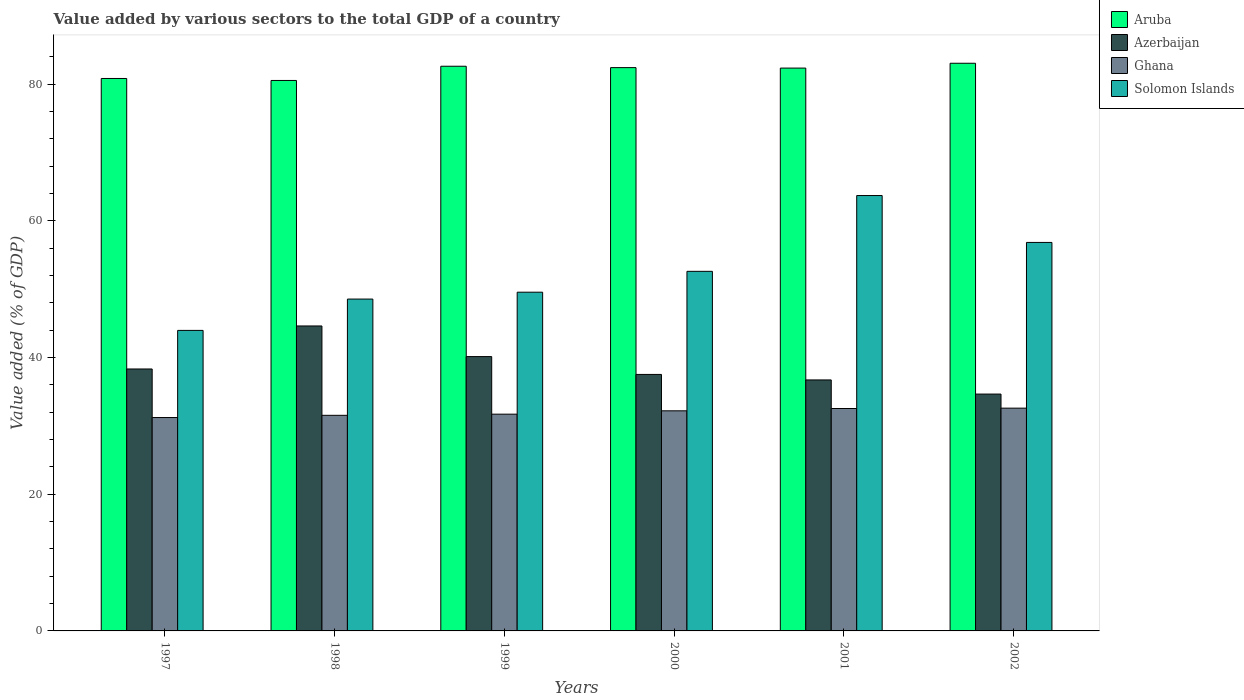How many different coloured bars are there?
Provide a short and direct response. 4. Are the number of bars per tick equal to the number of legend labels?
Offer a very short reply. Yes. How many bars are there on the 5th tick from the left?
Your answer should be compact. 4. How many bars are there on the 4th tick from the right?
Give a very brief answer. 4. In how many cases, is the number of bars for a given year not equal to the number of legend labels?
Your answer should be compact. 0. What is the value added by various sectors to the total GDP in Aruba in 1998?
Keep it short and to the point. 80.53. Across all years, what is the maximum value added by various sectors to the total GDP in Solomon Islands?
Make the answer very short. 63.69. Across all years, what is the minimum value added by various sectors to the total GDP in Azerbaijan?
Your response must be concise. 34.65. In which year was the value added by various sectors to the total GDP in Ghana maximum?
Give a very brief answer. 2002. What is the total value added by various sectors to the total GDP in Aruba in the graph?
Your response must be concise. 491.75. What is the difference between the value added by various sectors to the total GDP in Azerbaijan in 1998 and that in 2000?
Provide a short and direct response. 7.09. What is the difference between the value added by various sectors to the total GDP in Azerbaijan in 1997 and the value added by various sectors to the total GDP in Aruba in 1998?
Provide a short and direct response. -42.21. What is the average value added by various sectors to the total GDP in Aruba per year?
Provide a short and direct response. 81.96. In the year 2002, what is the difference between the value added by various sectors to the total GDP in Solomon Islands and value added by various sectors to the total GDP in Azerbaijan?
Your answer should be very brief. 22.18. In how many years, is the value added by various sectors to the total GDP in Azerbaijan greater than 76 %?
Provide a succinct answer. 0. What is the ratio of the value added by various sectors to the total GDP in Solomon Islands in 2001 to that in 2002?
Ensure brevity in your answer.  1.12. Is the value added by various sectors to the total GDP in Ghana in 2000 less than that in 2001?
Offer a terse response. Yes. Is the difference between the value added by various sectors to the total GDP in Solomon Islands in 1999 and 2002 greater than the difference between the value added by various sectors to the total GDP in Azerbaijan in 1999 and 2002?
Ensure brevity in your answer.  No. What is the difference between the highest and the second highest value added by various sectors to the total GDP in Solomon Islands?
Make the answer very short. 6.86. What is the difference between the highest and the lowest value added by various sectors to the total GDP in Solomon Islands?
Ensure brevity in your answer.  19.73. In how many years, is the value added by various sectors to the total GDP in Azerbaijan greater than the average value added by various sectors to the total GDP in Azerbaijan taken over all years?
Your answer should be compact. 2. Is the sum of the value added by various sectors to the total GDP in Aruba in 1998 and 2001 greater than the maximum value added by various sectors to the total GDP in Azerbaijan across all years?
Keep it short and to the point. Yes. What does the 4th bar from the left in 1998 represents?
Offer a terse response. Solomon Islands. What does the 1st bar from the right in 2002 represents?
Keep it short and to the point. Solomon Islands. Is it the case that in every year, the sum of the value added by various sectors to the total GDP in Ghana and value added by various sectors to the total GDP in Solomon Islands is greater than the value added by various sectors to the total GDP in Azerbaijan?
Give a very brief answer. Yes. Are all the bars in the graph horizontal?
Your response must be concise. No. How many years are there in the graph?
Offer a very short reply. 6. What is the difference between two consecutive major ticks on the Y-axis?
Provide a short and direct response. 20. Are the values on the major ticks of Y-axis written in scientific E-notation?
Offer a terse response. No. Where does the legend appear in the graph?
Your answer should be very brief. Top right. How are the legend labels stacked?
Ensure brevity in your answer.  Vertical. What is the title of the graph?
Offer a terse response. Value added by various sectors to the total GDP of a country. Does "Czech Republic" appear as one of the legend labels in the graph?
Ensure brevity in your answer.  No. What is the label or title of the Y-axis?
Your answer should be very brief. Value added (% of GDP). What is the Value added (% of GDP) in Aruba in 1997?
Keep it short and to the point. 80.82. What is the Value added (% of GDP) of Azerbaijan in 1997?
Offer a very short reply. 38.32. What is the Value added (% of GDP) of Ghana in 1997?
Provide a short and direct response. 31.22. What is the Value added (% of GDP) of Solomon Islands in 1997?
Offer a very short reply. 43.96. What is the Value added (% of GDP) in Aruba in 1998?
Your answer should be very brief. 80.53. What is the Value added (% of GDP) in Azerbaijan in 1998?
Your response must be concise. 44.61. What is the Value added (% of GDP) in Ghana in 1998?
Offer a terse response. 31.54. What is the Value added (% of GDP) in Solomon Islands in 1998?
Make the answer very short. 48.55. What is the Value added (% of GDP) of Aruba in 1999?
Your answer should be very brief. 82.61. What is the Value added (% of GDP) in Azerbaijan in 1999?
Your answer should be very brief. 40.13. What is the Value added (% of GDP) in Ghana in 1999?
Provide a short and direct response. 31.71. What is the Value added (% of GDP) of Solomon Islands in 1999?
Your answer should be compact. 49.55. What is the Value added (% of GDP) in Aruba in 2000?
Make the answer very short. 82.41. What is the Value added (% of GDP) in Azerbaijan in 2000?
Provide a short and direct response. 37.52. What is the Value added (% of GDP) in Ghana in 2000?
Give a very brief answer. 32.2. What is the Value added (% of GDP) of Solomon Islands in 2000?
Offer a terse response. 52.6. What is the Value added (% of GDP) in Aruba in 2001?
Provide a succinct answer. 82.34. What is the Value added (% of GDP) in Azerbaijan in 2001?
Give a very brief answer. 36.72. What is the Value added (% of GDP) of Ghana in 2001?
Offer a terse response. 32.54. What is the Value added (% of GDP) in Solomon Islands in 2001?
Provide a short and direct response. 63.69. What is the Value added (% of GDP) in Aruba in 2002?
Offer a terse response. 83.04. What is the Value added (% of GDP) of Azerbaijan in 2002?
Keep it short and to the point. 34.65. What is the Value added (% of GDP) in Ghana in 2002?
Offer a very short reply. 32.59. What is the Value added (% of GDP) of Solomon Islands in 2002?
Make the answer very short. 56.83. Across all years, what is the maximum Value added (% of GDP) in Aruba?
Your response must be concise. 83.04. Across all years, what is the maximum Value added (% of GDP) in Azerbaijan?
Offer a terse response. 44.61. Across all years, what is the maximum Value added (% of GDP) in Ghana?
Offer a very short reply. 32.59. Across all years, what is the maximum Value added (% of GDP) of Solomon Islands?
Ensure brevity in your answer.  63.69. Across all years, what is the minimum Value added (% of GDP) of Aruba?
Ensure brevity in your answer.  80.53. Across all years, what is the minimum Value added (% of GDP) in Azerbaijan?
Offer a very short reply. 34.65. Across all years, what is the minimum Value added (% of GDP) of Ghana?
Offer a terse response. 31.22. Across all years, what is the minimum Value added (% of GDP) of Solomon Islands?
Your response must be concise. 43.96. What is the total Value added (% of GDP) in Aruba in the graph?
Provide a short and direct response. 491.75. What is the total Value added (% of GDP) in Azerbaijan in the graph?
Provide a short and direct response. 231.96. What is the total Value added (% of GDP) of Ghana in the graph?
Your response must be concise. 191.79. What is the total Value added (% of GDP) of Solomon Islands in the graph?
Provide a short and direct response. 315.2. What is the difference between the Value added (% of GDP) in Aruba in 1997 and that in 1998?
Provide a succinct answer. 0.29. What is the difference between the Value added (% of GDP) of Azerbaijan in 1997 and that in 1998?
Your response must be concise. -6.29. What is the difference between the Value added (% of GDP) of Ghana in 1997 and that in 1998?
Provide a short and direct response. -0.32. What is the difference between the Value added (% of GDP) in Solomon Islands in 1997 and that in 1998?
Offer a terse response. -4.59. What is the difference between the Value added (% of GDP) in Aruba in 1997 and that in 1999?
Make the answer very short. -1.79. What is the difference between the Value added (% of GDP) of Azerbaijan in 1997 and that in 1999?
Your answer should be compact. -1.81. What is the difference between the Value added (% of GDP) in Ghana in 1997 and that in 1999?
Make the answer very short. -0.49. What is the difference between the Value added (% of GDP) of Solomon Islands in 1997 and that in 1999?
Your response must be concise. -5.59. What is the difference between the Value added (% of GDP) in Aruba in 1997 and that in 2000?
Offer a terse response. -1.59. What is the difference between the Value added (% of GDP) in Azerbaijan in 1997 and that in 2000?
Your answer should be very brief. 0.8. What is the difference between the Value added (% of GDP) in Ghana in 1997 and that in 2000?
Offer a very short reply. -0.98. What is the difference between the Value added (% of GDP) in Solomon Islands in 1997 and that in 2000?
Keep it short and to the point. -8.64. What is the difference between the Value added (% of GDP) of Aruba in 1997 and that in 2001?
Provide a succinct answer. -1.52. What is the difference between the Value added (% of GDP) in Azerbaijan in 1997 and that in 2001?
Offer a terse response. 1.6. What is the difference between the Value added (% of GDP) of Ghana in 1997 and that in 2001?
Provide a short and direct response. -1.32. What is the difference between the Value added (% of GDP) in Solomon Islands in 1997 and that in 2001?
Provide a short and direct response. -19.73. What is the difference between the Value added (% of GDP) of Aruba in 1997 and that in 2002?
Your answer should be compact. -2.23. What is the difference between the Value added (% of GDP) of Azerbaijan in 1997 and that in 2002?
Offer a very short reply. 3.67. What is the difference between the Value added (% of GDP) of Ghana in 1997 and that in 2002?
Keep it short and to the point. -1.37. What is the difference between the Value added (% of GDP) of Solomon Islands in 1997 and that in 2002?
Your response must be concise. -12.87. What is the difference between the Value added (% of GDP) of Aruba in 1998 and that in 1999?
Make the answer very short. -2.08. What is the difference between the Value added (% of GDP) in Azerbaijan in 1998 and that in 1999?
Keep it short and to the point. 4.48. What is the difference between the Value added (% of GDP) in Ghana in 1998 and that in 1999?
Give a very brief answer. -0.17. What is the difference between the Value added (% of GDP) in Solomon Islands in 1998 and that in 1999?
Your answer should be very brief. -1.01. What is the difference between the Value added (% of GDP) in Aruba in 1998 and that in 2000?
Your response must be concise. -1.88. What is the difference between the Value added (% of GDP) of Azerbaijan in 1998 and that in 2000?
Your response must be concise. 7.09. What is the difference between the Value added (% of GDP) of Ghana in 1998 and that in 2000?
Your response must be concise. -0.66. What is the difference between the Value added (% of GDP) of Solomon Islands in 1998 and that in 2000?
Your answer should be very brief. -4.06. What is the difference between the Value added (% of GDP) of Aruba in 1998 and that in 2001?
Provide a short and direct response. -1.81. What is the difference between the Value added (% of GDP) of Azerbaijan in 1998 and that in 2001?
Keep it short and to the point. 7.9. What is the difference between the Value added (% of GDP) of Ghana in 1998 and that in 2001?
Make the answer very short. -1. What is the difference between the Value added (% of GDP) of Solomon Islands in 1998 and that in 2001?
Ensure brevity in your answer.  -15.14. What is the difference between the Value added (% of GDP) of Aruba in 1998 and that in 2002?
Ensure brevity in your answer.  -2.52. What is the difference between the Value added (% of GDP) of Azerbaijan in 1998 and that in 2002?
Give a very brief answer. 9.96. What is the difference between the Value added (% of GDP) in Ghana in 1998 and that in 2002?
Keep it short and to the point. -1.05. What is the difference between the Value added (% of GDP) of Solomon Islands in 1998 and that in 2002?
Offer a terse response. -8.28. What is the difference between the Value added (% of GDP) of Aruba in 1999 and that in 2000?
Make the answer very short. 0.2. What is the difference between the Value added (% of GDP) in Azerbaijan in 1999 and that in 2000?
Your answer should be compact. 2.61. What is the difference between the Value added (% of GDP) of Ghana in 1999 and that in 2000?
Make the answer very short. -0.49. What is the difference between the Value added (% of GDP) in Solomon Islands in 1999 and that in 2000?
Provide a short and direct response. -3.05. What is the difference between the Value added (% of GDP) in Aruba in 1999 and that in 2001?
Offer a very short reply. 0.27. What is the difference between the Value added (% of GDP) in Azerbaijan in 1999 and that in 2001?
Your answer should be compact. 3.41. What is the difference between the Value added (% of GDP) in Ghana in 1999 and that in 2001?
Keep it short and to the point. -0.83. What is the difference between the Value added (% of GDP) in Solomon Islands in 1999 and that in 2001?
Offer a terse response. -14.14. What is the difference between the Value added (% of GDP) in Aruba in 1999 and that in 2002?
Provide a short and direct response. -0.44. What is the difference between the Value added (% of GDP) in Azerbaijan in 1999 and that in 2002?
Provide a succinct answer. 5.48. What is the difference between the Value added (% of GDP) of Ghana in 1999 and that in 2002?
Your answer should be very brief. -0.88. What is the difference between the Value added (% of GDP) in Solomon Islands in 1999 and that in 2002?
Your answer should be very brief. -7.28. What is the difference between the Value added (% of GDP) in Aruba in 2000 and that in 2001?
Offer a terse response. 0.07. What is the difference between the Value added (% of GDP) of Azerbaijan in 2000 and that in 2001?
Make the answer very short. 0.8. What is the difference between the Value added (% of GDP) of Ghana in 2000 and that in 2001?
Your answer should be compact. -0.34. What is the difference between the Value added (% of GDP) of Solomon Islands in 2000 and that in 2001?
Offer a terse response. -11.09. What is the difference between the Value added (% of GDP) in Aruba in 2000 and that in 2002?
Your response must be concise. -0.64. What is the difference between the Value added (% of GDP) in Azerbaijan in 2000 and that in 2002?
Provide a succinct answer. 2.87. What is the difference between the Value added (% of GDP) in Ghana in 2000 and that in 2002?
Your answer should be compact. -0.39. What is the difference between the Value added (% of GDP) in Solomon Islands in 2000 and that in 2002?
Provide a short and direct response. -4.23. What is the difference between the Value added (% of GDP) of Aruba in 2001 and that in 2002?
Give a very brief answer. -0.71. What is the difference between the Value added (% of GDP) in Azerbaijan in 2001 and that in 2002?
Give a very brief answer. 2.07. What is the difference between the Value added (% of GDP) of Ghana in 2001 and that in 2002?
Provide a succinct answer. -0.05. What is the difference between the Value added (% of GDP) in Solomon Islands in 2001 and that in 2002?
Keep it short and to the point. 6.86. What is the difference between the Value added (% of GDP) in Aruba in 1997 and the Value added (% of GDP) in Azerbaijan in 1998?
Offer a terse response. 36.21. What is the difference between the Value added (% of GDP) in Aruba in 1997 and the Value added (% of GDP) in Ghana in 1998?
Your response must be concise. 49.28. What is the difference between the Value added (% of GDP) in Aruba in 1997 and the Value added (% of GDP) in Solomon Islands in 1998?
Offer a terse response. 32.27. What is the difference between the Value added (% of GDP) of Azerbaijan in 1997 and the Value added (% of GDP) of Ghana in 1998?
Your response must be concise. 6.78. What is the difference between the Value added (% of GDP) in Azerbaijan in 1997 and the Value added (% of GDP) in Solomon Islands in 1998?
Make the answer very short. -10.23. What is the difference between the Value added (% of GDP) in Ghana in 1997 and the Value added (% of GDP) in Solomon Islands in 1998?
Your answer should be compact. -17.33. What is the difference between the Value added (% of GDP) of Aruba in 1997 and the Value added (% of GDP) of Azerbaijan in 1999?
Provide a short and direct response. 40.69. What is the difference between the Value added (% of GDP) in Aruba in 1997 and the Value added (% of GDP) in Ghana in 1999?
Provide a succinct answer. 49.11. What is the difference between the Value added (% of GDP) of Aruba in 1997 and the Value added (% of GDP) of Solomon Islands in 1999?
Make the answer very short. 31.27. What is the difference between the Value added (% of GDP) in Azerbaijan in 1997 and the Value added (% of GDP) in Ghana in 1999?
Provide a succinct answer. 6.61. What is the difference between the Value added (% of GDP) in Azerbaijan in 1997 and the Value added (% of GDP) in Solomon Islands in 1999?
Provide a short and direct response. -11.23. What is the difference between the Value added (% of GDP) in Ghana in 1997 and the Value added (% of GDP) in Solomon Islands in 1999?
Make the answer very short. -18.34. What is the difference between the Value added (% of GDP) of Aruba in 1997 and the Value added (% of GDP) of Azerbaijan in 2000?
Offer a terse response. 43.3. What is the difference between the Value added (% of GDP) of Aruba in 1997 and the Value added (% of GDP) of Ghana in 2000?
Provide a succinct answer. 48.62. What is the difference between the Value added (% of GDP) in Aruba in 1997 and the Value added (% of GDP) in Solomon Islands in 2000?
Your response must be concise. 28.22. What is the difference between the Value added (% of GDP) in Azerbaijan in 1997 and the Value added (% of GDP) in Ghana in 2000?
Give a very brief answer. 6.12. What is the difference between the Value added (% of GDP) of Azerbaijan in 1997 and the Value added (% of GDP) of Solomon Islands in 2000?
Your answer should be compact. -14.28. What is the difference between the Value added (% of GDP) of Ghana in 1997 and the Value added (% of GDP) of Solomon Islands in 2000?
Provide a succinct answer. -21.39. What is the difference between the Value added (% of GDP) in Aruba in 1997 and the Value added (% of GDP) in Azerbaijan in 2001?
Offer a very short reply. 44.1. What is the difference between the Value added (% of GDP) of Aruba in 1997 and the Value added (% of GDP) of Ghana in 2001?
Your answer should be very brief. 48.28. What is the difference between the Value added (% of GDP) of Aruba in 1997 and the Value added (% of GDP) of Solomon Islands in 2001?
Your response must be concise. 17.13. What is the difference between the Value added (% of GDP) in Azerbaijan in 1997 and the Value added (% of GDP) in Ghana in 2001?
Give a very brief answer. 5.78. What is the difference between the Value added (% of GDP) of Azerbaijan in 1997 and the Value added (% of GDP) of Solomon Islands in 2001?
Your answer should be very brief. -25.37. What is the difference between the Value added (% of GDP) of Ghana in 1997 and the Value added (% of GDP) of Solomon Islands in 2001?
Your response must be concise. -32.48. What is the difference between the Value added (% of GDP) in Aruba in 1997 and the Value added (% of GDP) in Azerbaijan in 2002?
Ensure brevity in your answer.  46.17. What is the difference between the Value added (% of GDP) of Aruba in 1997 and the Value added (% of GDP) of Ghana in 2002?
Make the answer very short. 48.23. What is the difference between the Value added (% of GDP) in Aruba in 1997 and the Value added (% of GDP) in Solomon Islands in 2002?
Make the answer very short. 23.99. What is the difference between the Value added (% of GDP) of Azerbaijan in 1997 and the Value added (% of GDP) of Ghana in 2002?
Your answer should be very brief. 5.73. What is the difference between the Value added (% of GDP) of Azerbaijan in 1997 and the Value added (% of GDP) of Solomon Islands in 2002?
Offer a very short reply. -18.51. What is the difference between the Value added (% of GDP) of Ghana in 1997 and the Value added (% of GDP) of Solomon Islands in 2002?
Offer a very short reply. -25.62. What is the difference between the Value added (% of GDP) of Aruba in 1998 and the Value added (% of GDP) of Azerbaijan in 1999?
Offer a very short reply. 40.4. What is the difference between the Value added (% of GDP) of Aruba in 1998 and the Value added (% of GDP) of Ghana in 1999?
Ensure brevity in your answer.  48.82. What is the difference between the Value added (% of GDP) of Aruba in 1998 and the Value added (% of GDP) of Solomon Islands in 1999?
Ensure brevity in your answer.  30.98. What is the difference between the Value added (% of GDP) of Azerbaijan in 1998 and the Value added (% of GDP) of Ghana in 1999?
Your answer should be very brief. 12.9. What is the difference between the Value added (% of GDP) of Azerbaijan in 1998 and the Value added (% of GDP) of Solomon Islands in 1999?
Offer a terse response. -4.94. What is the difference between the Value added (% of GDP) of Ghana in 1998 and the Value added (% of GDP) of Solomon Islands in 1999?
Give a very brief answer. -18.01. What is the difference between the Value added (% of GDP) in Aruba in 1998 and the Value added (% of GDP) in Azerbaijan in 2000?
Your answer should be very brief. 43.01. What is the difference between the Value added (% of GDP) of Aruba in 1998 and the Value added (% of GDP) of Ghana in 2000?
Provide a short and direct response. 48.33. What is the difference between the Value added (% of GDP) of Aruba in 1998 and the Value added (% of GDP) of Solomon Islands in 2000?
Your response must be concise. 27.93. What is the difference between the Value added (% of GDP) in Azerbaijan in 1998 and the Value added (% of GDP) in Ghana in 2000?
Your answer should be compact. 12.42. What is the difference between the Value added (% of GDP) in Azerbaijan in 1998 and the Value added (% of GDP) in Solomon Islands in 2000?
Keep it short and to the point. -7.99. What is the difference between the Value added (% of GDP) in Ghana in 1998 and the Value added (% of GDP) in Solomon Islands in 2000?
Offer a very short reply. -21.06. What is the difference between the Value added (% of GDP) in Aruba in 1998 and the Value added (% of GDP) in Azerbaijan in 2001?
Keep it short and to the point. 43.81. What is the difference between the Value added (% of GDP) in Aruba in 1998 and the Value added (% of GDP) in Ghana in 2001?
Your answer should be compact. 47.99. What is the difference between the Value added (% of GDP) in Aruba in 1998 and the Value added (% of GDP) in Solomon Islands in 2001?
Keep it short and to the point. 16.84. What is the difference between the Value added (% of GDP) of Azerbaijan in 1998 and the Value added (% of GDP) of Ghana in 2001?
Your answer should be compact. 12.08. What is the difference between the Value added (% of GDP) in Azerbaijan in 1998 and the Value added (% of GDP) in Solomon Islands in 2001?
Your answer should be very brief. -19.08. What is the difference between the Value added (% of GDP) of Ghana in 1998 and the Value added (% of GDP) of Solomon Islands in 2001?
Your answer should be very brief. -32.15. What is the difference between the Value added (% of GDP) in Aruba in 1998 and the Value added (% of GDP) in Azerbaijan in 2002?
Your answer should be compact. 45.88. What is the difference between the Value added (% of GDP) in Aruba in 1998 and the Value added (% of GDP) in Ghana in 2002?
Provide a succinct answer. 47.94. What is the difference between the Value added (% of GDP) in Aruba in 1998 and the Value added (% of GDP) in Solomon Islands in 2002?
Your response must be concise. 23.7. What is the difference between the Value added (% of GDP) of Azerbaijan in 1998 and the Value added (% of GDP) of Ghana in 2002?
Keep it short and to the point. 12.02. What is the difference between the Value added (% of GDP) of Azerbaijan in 1998 and the Value added (% of GDP) of Solomon Islands in 2002?
Provide a short and direct response. -12.22. What is the difference between the Value added (% of GDP) of Ghana in 1998 and the Value added (% of GDP) of Solomon Islands in 2002?
Ensure brevity in your answer.  -25.29. What is the difference between the Value added (% of GDP) of Aruba in 1999 and the Value added (% of GDP) of Azerbaijan in 2000?
Provide a succinct answer. 45.08. What is the difference between the Value added (% of GDP) of Aruba in 1999 and the Value added (% of GDP) of Ghana in 2000?
Provide a succinct answer. 50.41. What is the difference between the Value added (% of GDP) in Aruba in 1999 and the Value added (% of GDP) in Solomon Islands in 2000?
Your answer should be very brief. 30. What is the difference between the Value added (% of GDP) in Azerbaijan in 1999 and the Value added (% of GDP) in Ghana in 2000?
Give a very brief answer. 7.93. What is the difference between the Value added (% of GDP) of Azerbaijan in 1999 and the Value added (% of GDP) of Solomon Islands in 2000?
Give a very brief answer. -12.47. What is the difference between the Value added (% of GDP) in Ghana in 1999 and the Value added (% of GDP) in Solomon Islands in 2000?
Provide a short and direct response. -20.89. What is the difference between the Value added (% of GDP) in Aruba in 1999 and the Value added (% of GDP) in Azerbaijan in 2001?
Offer a very short reply. 45.89. What is the difference between the Value added (% of GDP) of Aruba in 1999 and the Value added (% of GDP) of Ghana in 2001?
Your answer should be very brief. 50.07. What is the difference between the Value added (% of GDP) in Aruba in 1999 and the Value added (% of GDP) in Solomon Islands in 2001?
Ensure brevity in your answer.  18.92. What is the difference between the Value added (% of GDP) of Azerbaijan in 1999 and the Value added (% of GDP) of Ghana in 2001?
Provide a short and direct response. 7.6. What is the difference between the Value added (% of GDP) in Azerbaijan in 1999 and the Value added (% of GDP) in Solomon Islands in 2001?
Provide a short and direct response. -23.56. What is the difference between the Value added (% of GDP) of Ghana in 1999 and the Value added (% of GDP) of Solomon Islands in 2001?
Your answer should be very brief. -31.98. What is the difference between the Value added (% of GDP) of Aruba in 1999 and the Value added (% of GDP) of Azerbaijan in 2002?
Your response must be concise. 47.96. What is the difference between the Value added (% of GDP) of Aruba in 1999 and the Value added (% of GDP) of Ghana in 2002?
Your answer should be compact. 50.02. What is the difference between the Value added (% of GDP) in Aruba in 1999 and the Value added (% of GDP) in Solomon Islands in 2002?
Ensure brevity in your answer.  25.77. What is the difference between the Value added (% of GDP) in Azerbaijan in 1999 and the Value added (% of GDP) in Ghana in 2002?
Your answer should be very brief. 7.54. What is the difference between the Value added (% of GDP) of Azerbaijan in 1999 and the Value added (% of GDP) of Solomon Islands in 2002?
Make the answer very short. -16.7. What is the difference between the Value added (% of GDP) in Ghana in 1999 and the Value added (% of GDP) in Solomon Islands in 2002?
Your answer should be compact. -25.12. What is the difference between the Value added (% of GDP) in Aruba in 2000 and the Value added (% of GDP) in Azerbaijan in 2001?
Your response must be concise. 45.69. What is the difference between the Value added (% of GDP) in Aruba in 2000 and the Value added (% of GDP) in Ghana in 2001?
Offer a terse response. 49.87. What is the difference between the Value added (% of GDP) of Aruba in 2000 and the Value added (% of GDP) of Solomon Islands in 2001?
Ensure brevity in your answer.  18.71. What is the difference between the Value added (% of GDP) of Azerbaijan in 2000 and the Value added (% of GDP) of Ghana in 2001?
Your answer should be compact. 4.99. What is the difference between the Value added (% of GDP) in Azerbaijan in 2000 and the Value added (% of GDP) in Solomon Islands in 2001?
Provide a short and direct response. -26.17. What is the difference between the Value added (% of GDP) of Ghana in 2000 and the Value added (% of GDP) of Solomon Islands in 2001?
Offer a terse response. -31.49. What is the difference between the Value added (% of GDP) in Aruba in 2000 and the Value added (% of GDP) in Azerbaijan in 2002?
Ensure brevity in your answer.  47.76. What is the difference between the Value added (% of GDP) of Aruba in 2000 and the Value added (% of GDP) of Ghana in 2002?
Your answer should be compact. 49.82. What is the difference between the Value added (% of GDP) in Aruba in 2000 and the Value added (% of GDP) in Solomon Islands in 2002?
Your response must be concise. 25.57. What is the difference between the Value added (% of GDP) in Azerbaijan in 2000 and the Value added (% of GDP) in Ghana in 2002?
Ensure brevity in your answer.  4.93. What is the difference between the Value added (% of GDP) in Azerbaijan in 2000 and the Value added (% of GDP) in Solomon Islands in 2002?
Provide a short and direct response. -19.31. What is the difference between the Value added (% of GDP) in Ghana in 2000 and the Value added (% of GDP) in Solomon Islands in 2002?
Offer a very short reply. -24.63. What is the difference between the Value added (% of GDP) in Aruba in 2001 and the Value added (% of GDP) in Azerbaijan in 2002?
Give a very brief answer. 47.69. What is the difference between the Value added (% of GDP) of Aruba in 2001 and the Value added (% of GDP) of Ghana in 2002?
Your answer should be very brief. 49.75. What is the difference between the Value added (% of GDP) in Aruba in 2001 and the Value added (% of GDP) in Solomon Islands in 2002?
Offer a very short reply. 25.51. What is the difference between the Value added (% of GDP) of Azerbaijan in 2001 and the Value added (% of GDP) of Ghana in 2002?
Your response must be concise. 4.13. What is the difference between the Value added (% of GDP) of Azerbaijan in 2001 and the Value added (% of GDP) of Solomon Islands in 2002?
Offer a very short reply. -20.11. What is the difference between the Value added (% of GDP) in Ghana in 2001 and the Value added (% of GDP) in Solomon Islands in 2002?
Offer a terse response. -24.3. What is the average Value added (% of GDP) of Aruba per year?
Your answer should be very brief. 81.96. What is the average Value added (% of GDP) of Azerbaijan per year?
Your response must be concise. 38.66. What is the average Value added (% of GDP) of Ghana per year?
Provide a succinct answer. 31.97. What is the average Value added (% of GDP) in Solomon Islands per year?
Your response must be concise. 52.53. In the year 1997, what is the difference between the Value added (% of GDP) in Aruba and Value added (% of GDP) in Azerbaijan?
Ensure brevity in your answer.  42.5. In the year 1997, what is the difference between the Value added (% of GDP) of Aruba and Value added (% of GDP) of Ghana?
Provide a short and direct response. 49.6. In the year 1997, what is the difference between the Value added (% of GDP) in Aruba and Value added (% of GDP) in Solomon Islands?
Give a very brief answer. 36.86. In the year 1997, what is the difference between the Value added (% of GDP) of Azerbaijan and Value added (% of GDP) of Ghana?
Offer a very short reply. 7.1. In the year 1997, what is the difference between the Value added (% of GDP) of Azerbaijan and Value added (% of GDP) of Solomon Islands?
Offer a very short reply. -5.64. In the year 1997, what is the difference between the Value added (% of GDP) in Ghana and Value added (% of GDP) in Solomon Islands?
Your answer should be compact. -12.75. In the year 1998, what is the difference between the Value added (% of GDP) of Aruba and Value added (% of GDP) of Azerbaijan?
Make the answer very short. 35.91. In the year 1998, what is the difference between the Value added (% of GDP) of Aruba and Value added (% of GDP) of Ghana?
Keep it short and to the point. 48.99. In the year 1998, what is the difference between the Value added (% of GDP) of Aruba and Value added (% of GDP) of Solomon Islands?
Your response must be concise. 31.98. In the year 1998, what is the difference between the Value added (% of GDP) in Azerbaijan and Value added (% of GDP) in Ghana?
Your response must be concise. 13.07. In the year 1998, what is the difference between the Value added (% of GDP) in Azerbaijan and Value added (% of GDP) in Solomon Islands?
Ensure brevity in your answer.  -3.93. In the year 1998, what is the difference between the Value added (% of GDP) in Ghana and Value added (% of GDP) in Solomon Islands?
Your response must be concise. -17.01. In the year 1999, what is the difference between the Value added (% of GDP) of Aruba and Value added (% of GDP) of Azerbaijan?
Your answer should be very brief. 42.47. In the year 1999, what is the difference between the Value added (% of GDP) of Aruba and Value added (% of GDP) of Ghana?
Make the answer very short. 50.9. In the year 1999, what is the difference between the Value added (% of GDP) in Aruba and Value added (% of GDP) in Solomon Islands?
Make the answer very short. 33.05. In the year 1999, what is the difference between the Value added (% of GDP) in Azerbaijan and Value added (% of GDP) in Ghana?
Offer a very short reply. 8.42. In the year 1999, what is the difference between the Value added (% of GDP) in Azerbaijan and Value added (% of GDP) in Solomon Islands?
Offer a terse response. -9.42. In the year 1999, what is the difference between the Value added (% of GDP) in Ghana and Value added (% of GDP) in Solomon Islands?
Give a very brief answer. -17.84. In the year 2000, what is the difference between the Value added (% of GDP) of Aruba and Value added (% of GDP) of Azerbaijan?
Keep it short and to the point. 44.88. In the year 2000, what is the difference between the Value added (% of GDP) of Aruba and Value added (% of GDP) of Ghana?
Your response must be concise. 50.21. In the year 2000, what is the difference between the Value added (% of GDP) in Aruba and Value added (% of GDP) in Solomon Islands?
Keep it short and to the point. 29.8. In the year 2000, what is the difference between the Value added (% of GDP) of Azerbaijan and Value added (% of GDP) of Ghana?
Your answer should be very brief. 5.32. In the year 2000, what is the difference between the Value added (% of GDP) in Azerbaijan and Value added (% of GDP) in Solomon Islands?
Keep it short and to the point. -15.08. In the year 2000, what is the difference between the Value added (% of GDP) in Ghana and Value added (% of GDP) in Solomon Islands?
Your answer should be compact. -20.41. In the year 2001, what is the difference between the Value added (% of GDP) of Aruba and Value added (% of GDP) of Azerbaijan?
Your answer should be compact. 45.62. In the year 2001, what is the difference between the Value added (% of GDP) in Aruba and Value added (% of GDP) in Ghana?
Your response must be concise. 49.8. In the year 2001, what is the difference between the Value added (% of GDP) in Aruba and Value added (% of GDP) in Solomon Islands?
Provide a succinct answer. 18.65. In the year 2001, what is the difference between the Value added (% of GDP) of Azerbaijan and Value added (% of GDP) of Ghana?
Give a very brief answer. 4.18. In the year 2001, what is the difference between the Value added (% of GDP) of Azerbaijan and Value added (% of GDP) of Solomon Islands?
Your answer should be compact. -26.97. In the year 2001, what is the difference between the Value added (% of GDP) in Ghana and Value added (% of GDP) in Solomon Islands?
Your response must be concise. -31.16. In the year 2002, what is the difference between the Value added (% of GDP) of Aruba and Value added (% of GDP) of Azerbaijan?
Your answer should be very brief. 48.4. In the year 2002, what is the difference between the Value added (% of GDP) in Aruba and Value added (% of GDP) in Ghana?
Provide a short and direct response. 50.45. In the year 2002, what is the difference between the Value added (% of GDP) in Aruba and Value added (% of GDP) in Solomon Islands?
Provide a succinct answer. 26.21. In the year 2002, what is the difference between the Value added (% of GDP) of Azerbaijan and Value added (% of GDP) of Ghana?
Offer a terse response. 2.06. In the year 2002, what is the difference between the Value added (% of GDP) in Azerbaijan and Value added (% of GDP) in Solomon Islands?
Provide a short and direct response. -22.18. In the year 2002, what is the difference between the Value added (% of GDP) in Ghana and Value added (% of GDP) in Solomon Islands?
Give a very brief answer. -24.24. What is the ratio of the Value added (% of GDP) of Azerbaijan in 1997 to that in 1998?
Offer a very short reply. 0.86. What is the ratio of the Value added (% of GDP) of Ghana in 1997 to that in 1998?
Provide a succinct answer. 0.99. What is the ratio of the Value added (% of GDP) in Solomon Islands in 1997 to that in 1998?
Provide a short and direct response. 0.91. What is the ratio of the Value added (% of GDP) in Aruba in 1997 to that in 1999?
Your answer should be very brief. 0.98. What is the ratio of the Value added (% of GDP) of Azerbaijan in 1997 to that in 1999?
Your answer should be compact. 0.95. What is the ratio of the Value added (% of GDP) of Ghana in 1997 to that in 1999?
Make the answer very short. 0.98. What is the ratio of the Value added (% of GDP) of Solomon Islands in 1997 to that in 1999?
Provide a short and direct response. 0.89. What is the ratio of the Value added (% of GDP) in Aruba in 1997 to that in 2000?
Your answer should be very brief. 0.98. What is the ratio of the Value added (% of GDP) of Azerbaijan in 1997 to that in 2000?
Your response must be concise. 1.02. What is the ratio of the Value added (% of GDP) of Ghana in 1997 to that in 2000?
Offer a very short reply. 0.97. What is the ratio of the Value added (% of GDP) of Solomon Islands in 1997 to that in 2000?
Your response must be concise. 0.84. What is the ratio of the Value added (% of GDP) in Aruba in 1997 to that in 2001?
Give a very brief answer. 0.98. What is the ratio of the Value added (% of GDP) of Azerbaijan in 1997 to that in 2001?
Provide a short and direct response. 1.04. What is the ratio of the Value added (% of GDP) of Ghana in 1997 to that in 2001?
Your response must be concise. 0.96. What is the ratio of the Value added (% of GDP) of Solomon Islands in 1997 to that in 2001?
Give a very brief answer. 0.69. What is the ratio of the Value added (% of GDP) in Aruba in 1997 to that in 2002?
Give a very brief answer. 0.97. What is the ratio of the Value added (% of GDP) of Azerbaijan in 1997 to that in 2002?
Ensure brevity in your answer.  1.11. What is the ratio of the Value added (% of GDP) in Ghana in 1997 to that in 2002?
Offer a very short reply. 0.96. What is the ratio of the Value added (% of GDP) of Solomon Islands in 1997 to that in 2002?
Provide a short and direct response. 0.77. What is the ratio of the Value added (% of GDP) of Aruba in 1998 to that in 1999?
Your answer should be very brief. 0.97. What is the ratio of the Value added (% of GDP) of Azerbaijan in 1998 to that in 1999?
Make the answer very short. 1.11. What is the ratio of the Value added (% of GDP) of Ghana in 1998 to that in 1999?
Your response must be concise. 0.99. What is the ratio of the Value added (% of GDP) of Solomon Islands in 1998 to that in 1999?
Ensure brevity in your answer.  0.98. What is the ratio of the Value added (% of GDP) in Aruba in 1998 to that in 2000?
Make the answer very short. 0.98. What is the ratio of the Value added (% of GDP) of Azerbaijan in 1998 to that in 2000?
Provide a short and direct response. 1.19. What is the ratio of the Value added (% of GDP) in Ghana in 1998 to that in 2000?
Offer a terse response. 0.98. What is the ratio of the Value added (% of GDP) of Solomon Islands in 1998 to that in 2000?
Ensure brevity in your answer.  0.92. What is the ratio of the Value added (% of GDP) in Azerbaijan in 1998 to that in 2001?
Your response must be concise. 1.22. What is the ratio of the Value added (% of GDP) of Ghana in 1998 to that in 2001?
Your response must be concise. 0.97. What is the ratio of the Value added (% of GDP) in Solomon Islands in 1998 to that in 2001?
Make the answer very short. 0.76. What is the ratio of the Value added (% of GDP) in Aruba in 1998 to that in 2002?
Keep it short and to the point. 0.97. What is the ratio of the Value added (% of GDP) of Azerbaijan in 1998 to that in 2002?
Your response must be concise. 1.29. What is the ratio of the Value added (% of GDP) of Ghana in 1998 to that in 2002?
Offer a very short reply. 0.97. What is the ratio of the Value added (% of GDP) in Solomon Islands in 1998 to that in 2002?
Provide a succinct answer. 0.85. What is the ratio of the Value added (% of GDP) in Aruba in 1999 to that in 2000?
Ensure brevity in your answer.  1. What is the ratio of the Value added (% of GDP) of Azerbaijan in 1999 to that in 2000?
Provide a short and direct response. 1.07. What is the ratio of the Value added (% of GDP) of Solomon Islands in 1999 to that in 2000?
Your response must be concise. 0.94. What is the ratio of the Value added (% of GDP) of Aruba in 1999 to that in 2001?
Offer a very short reply. 1. What is the ratio of the Value added (% of GDP) in Azerbaijan in 1999 to that in 2001?
Offer a terse response. 1.09. What is the ratio of the Value added (% of GDP) in Ghana in 1999 to that in 2001?
Give a very brief answer. 0.97. What is the ratio of the Value added (% of GDP) in Solomon Islands in 1999 to that in 2001?
Ensure brevity in your answer.  0.78. What is the ratio of the Value added (% of GDP) of Aruba in 1999 to that in 2002?
Ensure brevity in your answer.  0.99. What is the ratio of the Value added (% of GDP) in Azerbaijan in 1999 to that in 2002?
Provide a short and direct response. 1.16. What is the ratio of the Value added (% of GDP) in Ghana in 1999 to that in 2002?
Your answer should be very brief. 0.97. What is the ratio of the Value added (% of GDP) of Solomon Islands in 1999 to that in 2002?
Give a very brief answer. 0.87. What is the ratio of the Value added (% of GDP) of Azerbaijan in 2000 to that in 2001?
Your answer should be very brief. 1.02. What is the ratio of the Value added (% of GDP) of Ghana in 2000 to that in 2001?
Your answer should be compact. 0.99. What is the ratio of the Value added (% of GDP) in Solomon Islands in 2000 to that in 2001?
Keep it short and to the point. 0.83. What is the ratio of the Value added (% of GDP) of Azerbaijan in 2000 to that in 2002?
Keep it short and to the point. 1.08. What is the ratio of the Value added (% of GDP) of Solomon Islands in 2000 to that in 2002?
Ensure brevity in your answer.  0.93. What is the ratio of the Value added (% of GDP) in Aruba in 2001 to that in 2002?
Give a very brief answer. 0.99. What is the ratio of the Value added (% of GDP) in Azerbaijan in 2001 to that in 2002?
Your answer should be very brief. 1.06. What is the ratio of the Value added (% of GDP) in Ghana in 2001 to that in 2002?
Provide a succinct answer. 1. What is the ratio of the Value added (% of GDP) of Solomon Islands in 2001 to that in 2002?
Offer a very short reply. 1.12. What is the difference between the highest and the second highest Value added (% of GDP) of Aruba?
Offer a terse response. 0.44. What is the difference between the highest and the second highest Value added (% of GDP) of Azerbaijan?
Make the answer very short. 4.48. What is the difference between the highest and the second highest Value added (% of GDP) in Ghana?
Give a very brief answer. 0.05. What is the difference between the highest and the second highest Value added (% of GDP) in Solomon Islands?
Your response must be concise. 6.86. What is the difference between the highest and the lowest Value added (% of GDP) in Aruba?
Offer a very short reply. 2.52. What is the difference between the highest and the lowest Value added (% of GDP) in Azerbaijan?
Provide a succinct answer. 9.96. What is the difference between the highest and the lowest Value added (% of GDP) in Ghana?
Your answer should be compact. 1.37. What is the difference between the highest and the lowest Value added (% of GDP) in Solomon Islands?
Make the answer very short. 19.73. 